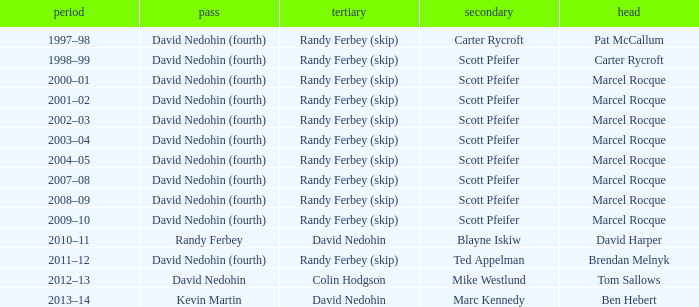Which Skip has a Season of 2002–03? David Nedohin (fourth). Would you mind parsing the complete table? {'header': ['period', 'pass', 'tertiary', 'secondary', 'head'], 'rows': [['1997–98', 'David Nedohin (fourth)', 'Randy Ferbey (skip)', 'Carter Rycroft', 'Pat McCallum'], ['1998–99', 'David Nedohin (fourth)', 'Randy Ferbey (skip)', 'Scott Pfeifer', 'Carter Rycroft'], ['2000–01', 'David Nedohin (fourth)', 'Randy Ferbey (skip)', 'Scott Pfeifer', 'Marcel Rocque'], ['2001–02', 'David Nedohin (fourth)', 'Randy Ferbey (skip)', 'Scott Pfeifer', 'Marcel Rocque'], ['2002–03', 'David Nedohin (fourth)', 'Randy Ferbey (skip)', 'Scott Pfeifer', 'Marcel Rocque'], ['2003–04', 'David Nedohin (fourth)', 'Randy Ferbey (skip)', 'Scott Pfeifer', 'Marcel Rocque'], ['2004–05', 'David Nedohin (fourth)', 'Randy Ferbey (skip)', 'Scott Pfeifer', 'Marcel Rocque'], ['2007–08', 'David Nedohin (fourth)', 'Randy Ferbey (skip)', 'Scott Pfeifer', 'Marcel Rocque'], ['2008–09', 'David Nedohin (fourth)', 'Randy Ferbey (skip)', 'Scott Pfeifer', 'Marcel Rocque'], ['2009–10', 'David Nedohin (fourth)', 'Randy Ferbey (skip)', 'Scott Pfeifer', 'Marcel Rocque'], ['2010–11', 'Randy Ferbey', 'David Nedohin', 'Blayne Iskiw', 'David Harper'], ['2011–12', 'David Nedohin (fourth)', 'Randy Ferbey (skip)', 'Ted Appelman', 'Brendan Melnyk'], ['2012–13', 'David Nedohin', 'Colin Hodgson', 'Mike Westlund', 'Tom Sallows'], ['2013–14', 'Kevin Martin', 'David Nedohin', 'Marc Kennedy', 'Ben Hebert']]} 